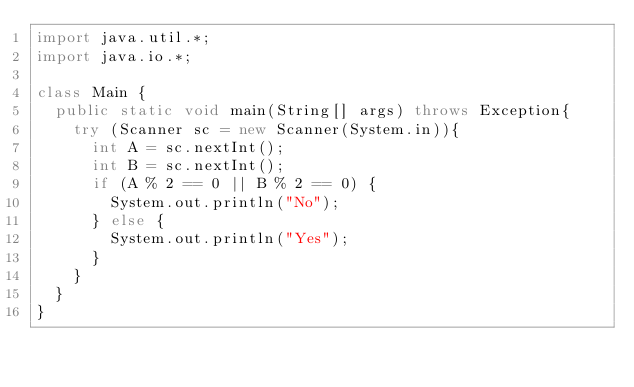Convert code to text. <code><loc_0><loc_0><loc_500><loc_500><_Java_>import java.util.*;
import java.io.*;

class Main {
  public static void main(String[] args) throws Exception{
    try (Scanner sc = new Scanner(System.in)){
      int A = sc.nextInt();
      int B = sc.nextInt();
      if (A % 2 == 0 || B % 2 == 0) {
        System.out.println("No");
      } else {
        System.out.println("Yes");
      }
    }
  }
}
</code> 